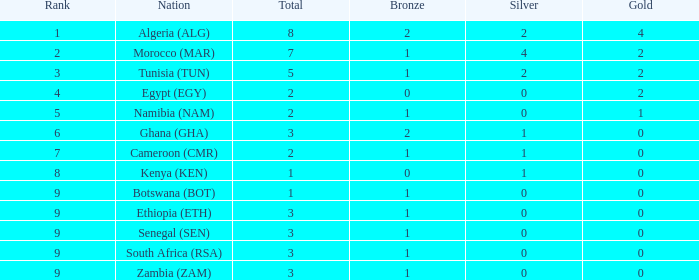What is the average Total with a Nation of ethiopia (eth) and a Rank that is larger than 9? None. 